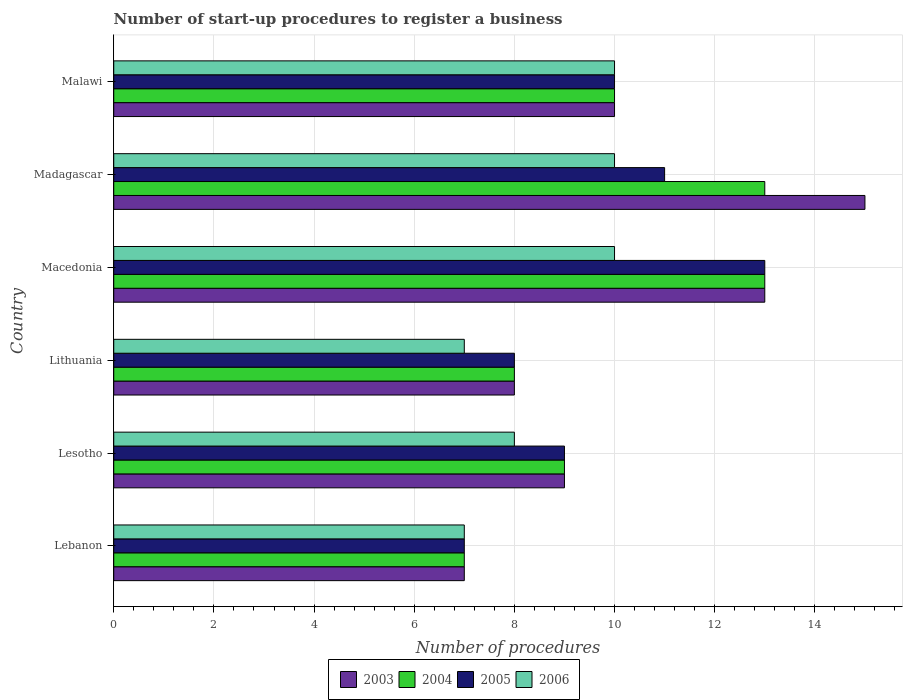How many different coloured bars are there?
Ensure brevity in your answer.  4. How many groups of bars are there?
Your answer should be compact. 6. Are the number of bars per tick equal to the number of legend labels?
Keep it short and to the point. Yes. Are the number of bars on each tick of the Y-axis equal?
Offer a very short reply. Yes. How many bars are there on the 4th tick from the top?
Offer a very short reply. 4. What is the label of the 6th group of bars from the top?
Provide a short and direct response. Lebanon. In which country was the number of procedures required to register a business in 2006 maximum?
Offer a terse response. Macedonia. In which country was the number of procedures required to register a business in 2005 minimum?
Make the answer very short. Lebanon. What is the total number of procedures required to register a business in 2003 in the graph?
Keep it short and to the point. 62. What is the difference between the number of procedures required to register a business in 2004 in Lesotho and that in Malawi?
Offer a terse response. -1. What is the average number of procedures required to register a business in 2004 per country?
Make the answer very short. 10. Is the number of procedures required to register a business in 2004 in Lithuania less than that in Macedonia?
Offer a very short reply. Yes. Is the difference between the number of procedures required to register a business in 2003 in Lesotho and Madagascar greater than the difference between the number of procedures required to register a business in 2005 in Lesotho and Madagascar?
Offer a very short reply. No. What is the difference between the highest and the lowest number of procedures required to register a business in 2004?
Provide a succinct answer. 6. Is the sum of the number of procedures required to register a business in 2006 in Macedonia and Malawi greater than the maximum number of procedures required to register a business in 2003 across all countries?
Keep it short and to the point. Yes. Is it the case that in every country, the sum of the number of procedures required to register a business in 2003 and number of procedures required to register a business in 2006 is greater than the number of procedures required to register a business in 2004?
Keep it short and to the point. Yes. How many bars are there?
Your answer should be compact. 24. What is the difference between two consecutive major ticks on the X-axis?
Provide a short and direct response. 2. Does the graph contain grids?
Offer a very short reply. Yes. What is the title of the graph?
Ensure brevity in your answer.  Number of start-up procedures to register a business. Does "1994" appear as one of the legend labels in the graph?
Give a very brief answer. No. What is the label or title of the X-axis?
Your response must be concise. Number of procedures. What is the label or title of the Y-axis?
Your answer should be very brief. Country. What is the Number of procedures of 2003 in Lebanon?
Offer a very short reply. 7. What is the Number of procedures of 2004 in Lebanon?
Your answer should be very brief. 7. What is the Number of procedures in 2005 in Lebanon?
Offer a terse response. 7. What is the Number of procedures of 2006 in Lebanon?
Give a very brief answer. 7. What is the Number of procedures in 2003 in Lesotho?
Your answer should be very brief. 9. What is the Number of procedures of 2004 in Lesotho?
Give a very brief answer. 9. What is the Number of procedures in 2006 in Lesotho?
Ensure brevity in your answer.  8. What is the Number of procedures of 2006 in Lithuania?
Your answer should be compact. 7. What is the Number of procedures in 2005 in Macedonia?
Your response must be concise. 13. What is the Number of procedures of 2004 in Madagascar?
Give a very brief answer. 13. What is the Number of procedures in 2006 in Madagascar?
Make the answer very short. 10. What is the Number of procedures in 2004 in Malawi?
Your answer should be very brief. 10. What is the Number of procedures of 2005 in Malawi?
Make the answer very short. 10. Across all countries, what is the maximum Number of procedures in 2003?
Provide a succinct answer. 15. Across all countries, what is the maximum Number of procedures in 2004?
Make the answer very short. 13. Across all countries, what is the maximum Number of procedures of 2006?
Keep it short and to the point. 10. Across all countries, what is the minimum Number of procedures of 2003?
Your answer should be very brief. 7. Across all countries, what is the minimum Number of procedures in 2004?
Offer a very short reply. 7. Across all countries, what is the minimum Number of procedures of 2005?
Offer a terse response. 7. Across all countries, what is the minimum Number of procedures in 2006?
Make the answer very short. 7. What is the total Number of procedures of 2003 in the graph?
Offer a very short reply. 62. What is the total Number of procedures of 2004 in the graph?
Your answer should be very brief. 60. What is the total Number of procedures in 2005 in the graph?
Offer a very short reply. 58. What is the difference between the Number of procedures in 2004 in Lebanon and that in Lesotho?
Provide a succinct answer. -2. What is the difference between the Number of procedures in 2006 in Lebanon and that in Lesotho?
Ensure brevity in your answer.  -1. What is the difference between the Number of procedures of 2004 in Lebanon and that in Lithuania?
Give a very brief answer. -1. What is the difference between the Number of procedures of 2005 in Lebanon and that in Lithuania?
Make the answer very short. -1. What is the difference between the Number of procedures of 2003 in Lebanon and that in Macedonia?
Offer a very short reply. -6. What is the difference between the Number of procedures of 2004 in Lebanon and that in Macedonia?
Offer a very short reply. -6. What is the difference between the Number of procedures of 2005 in Lebanon and that in Macedonia?
Give a very brief answer. -6. What is the difference between the Number of procedures of 2003 in Lebanon and that in Madagascar?
Ensure brevity in your answer.  -8. What is the difference between the Number of procedures of 2004 in Lebanon and that in Madagascar?
Offer a terse response. -6. What is the difference between the Number of procedures of 2005 in Lebanon and that in Madagascar?
Make the answer very short. -4. What is the difference between the Number of procedures of 2006 in Lebanon and that in Madagascar?
Ensure brevity in your answer.  -3. What is the difference between the Number of procedures of 2004 in Lebanon and that in Malawi?
Keep it short and to the point. -3. What is the difference between the Number of procedures in 2006 in Lebanon and that in Malawi?
Provide a short and direct response. -3. What is the difference between the Number of procedures of 2004 in Lesotho and that in Lithuania?
Provide a short and direct response. 1. What is the difference between the Number of procedures in 2006 in Lesotho and that in Lithuania?
Offer a very short reply. 1. What is the difference between the Number of procedures in 2003 in Lesotho and that in Macedonia?
Provide a succinct answer. -4. What is the difference between the Number of procedures of 2004 in Lesotho and that in Macedonia?
Give a very brief answer. -4. What is the difference between the Number of procedures of 2003 in Lesotho and that in Madagascar?
Your answer should be very brief. -6. What is the difference between the Number of procedures in 2005 in Lesotho and that in Madagascar?
Provide a succinct answer. -2. What is the difference between the Number of procedures of 2006 in Lesotho and that in Madagascar?
Offer a terse response. -2. What is the difference between the Number of procedures of 2003 in Lesotho and that in Malawi?
Make the answer very short. -1. What is the difference between the Number of procedures in 2004 in Lesotho and that in Malawi?
Provide a succinct answer. -1. What is the difference between the Number of procedures in 2005 in Lesotho and that in Malawi?
Make the answer very short. -1. What is the difference between the Number of procedures of 2006 in Lithuania and that in Macedonia?
Provide a short and direct response. -3. What is the difference between the Number of procedures in 2004 in Lithuania and that in Malawi?
Provide a short and direct response. -2. What is the difference between the Number of procedures in 2005 in Lithuania and that in Malawi?
Ensure brevity in your answer.  -2. What is the difference between the Number of procedures in 2003 in Macedonia and that in Madagascar?
Your answer should be very brief. -2. What is the difference between the Number of procedures in 2004 in Macedonia and that in Madagascar?
Give a very brief answer. 0. What is the difference between the Number of procedures in 2003 in Macedonia and that in Malawi?
Offer a very short reply. 3. What is the difference between the Number of procedures of 2005 in Macedonia and that in Malawi?
Offer a very short reply. 3. What is the difference between the Number of procedures of 2006 in Macedonia and that in Malawi?
Your answer should be very brief. 0. What is the difference between the Number of procedures of 2003 in Madagascar and that in Malawi?
Your response must be concise. 5. What is the difference between the Number of procedures of 2004 in Madagascar and that in Malawi?
Your response must be concise. 3. What is the difference between the Number of procedures in 2006 in Madagascar and that in Malawi?
Your response must be concise. 0. What is the difference between the Number of procedures in 2003 in Lebanon and the Number of procedures in 2005 in Lesotho?
Offer a very short reply. -2. What is the difference between the Number of procedures in 2004 in Lebanon and the Number of procedures in 2006 in Lesotho?
Ensure brevity in your answer.  -1. What is the difference between the Number of procedures of 2005 in Lebanon and the Number of procedures of 2006 in Lesotho?
Offer a very short reply. -1. What is the difference between the Number of procedures in 2003 in Lebanon and the Number of procedures in 2005 in Lithuania?
Offer a very short reply. -1. What is the difference between the Number of procedures of 2003 in Lebanon and the Number of procedures of 2006 in Lithuania?
Offer a terse response. 0. What is the difference between the Number of procedures of 2004 in Lebanon and the Number of procedures of 2006 in Lithuania?
Provide a succinct answer. 0. What is the difference between the Number of procedures of 2003 in Lebanon and the Number of procedures of 2004 in Macedonia?
Your response must be concise. -6. What is the difference between the Number of procedures in 2004 in Lebanon and the Number of procedures in 2006 in Macedonia?
Make the answer very short. -3. What is the difference between the Number of procedures in 2005 in Lebanon and the Number of procedures in 2006 in Macedonia?
Make the answer very short. -3. What is the difference between the Number of procedures of 2003 in Lebanon and the Number of procedures of 2005 in Madagascar?
Your response must be concise. -4. What is the difference between the Number of procedures of 2003 in Lebanon and the Number of procedures of 2006 in Madagascar?
Ensure brevity in your answer.  -3. What is the difference between the Number of procedures in 2004 in Lebanon and the Number of procedures in 2005 in Madagascar?
Provide a succinct answer. -4. What is the difference between the Number of procedures of 2005 in Lebanon and the Number of procedures of 2006 in Madagascar?
Keep it short and to the point. -3. What is the difference between the Number of procedures in 2004 in Lebanon and the Number of procedures in 2006 in Malawi?
Your answer should be compact. -3. What is the difference between the Number of procedures of 2003 in Lesotho and the Number of procedures of 2005 in Lithuania?
Provide a succinct answer. 1. What is the difference between the Number of procedures of 2003 in Lesotho and the Number of procedures of 2006 in Lithuania?
Ensure brevity in your answer.  2. What is the difference between the Number of procedures in 2004 in Lesotho and the Number of procedures in 2005 in Lithuania?
Provide a short and direct response. 1. What is the difference between the Number of procedures in 2004 in Lesotho and the Number of procedures in 2006 in Lithuania?
Your response must be concise. 2. What is the difference between the Number of procedures of 2005 in Lesotho and the Number of procedures of 2006 in Lithuania?
Provide a short and direct response. 2. What is the difference between the Number of procedures in 2003 in Lesotho and the Number of procedures in 2004 in Macedonia?
Provide a short and direct response. -4. What is the difference between the Number of procedures of 2003 in Lesotho and the Number of procedures of 2005 in Macedonia?
Offer a terse response. -4. What is the difference between the Number of procedures in 2004 in Lesotho and the Number of procedures in 2005 in Macedonia?
Keep it short and to the point. -4. What is the difference between the Number of procedures in 2004 in Lesotho and the Number of procedures in 2006 in Macedonia?
Provide a succinct answer. -1. What is the difference between the Number of procedures of 2003 in Lesotho and the Number of procedures of 2004 in Madagascar?
Make the answer very short. -4. What is the difference between the Number of procedures of 2003 in Lesotho and the Number of procedures of 2006 in Malawi?
Give a very brief answer. -1. What is the difference between the Number of procedures in 2003 in Lithuania and the Number of procedures in 2004 in Macedonia?
Make the answer very short. -5. What is the difference between the Number of procedures of 2003 in Lithuania and the Number of procedures of 2006 in Macedonia?
Give a very brief answer. -2. What is the difference between the Number of procedures of 2004 in Lithuania and the Number of procedures of 2005 in Macedonia?
Your response must be concise. -5. What is the difference between the Number of procedures in 2004 in Lithuania and the Number of procedures in 2006 in Macedonia?
Ensure brevity in your answer.  -2. What is the difference between the Number of procedures of 2005 in Lithuania and the Number of procedures of 2006 in Macedonia?
Make the answer very short. -2. What is the difference between the Number of procedures of 2003 in Lithuania and the Number of procedures of 2004 in Madagascar?
Your answer should be compact. -5. What is the difference between the Number of procedures in 2003 in Lithuania and the Number of procedures in 2005 in Madagascar?
Offer a very short reply. -3. What is the difference between the Number of procedures in 2004 in Lithuania and the Number of procedures in 2005 in Madagascar?
Give a very brief answer. -3. What is the difference between the Number of procedures in 2004 in Lithuania and the Number of procedures in 2006 in Madagascar?
Offer a terse response. -2. What is the difference between the Number of procedures of 2003 in Lithuania and the Number of procedures of 2004 in Malawi?
Your answer should be compact. -2. What is the difference between the Number of procedures in 2003 in Lithuania and the Number of procedures in 2005 in Malawi?
Keep it short and to the point. -2. What is the difference between the Number of procedures of 2005 in Lithuania and the Number of procedures of 2006 in Malawi?
Offer a terse response. -2. What is the difference between the Number of procedures of 2003 in Macedonia and the Number of procedures of 2004 in Madagascar?
Your response must be concise. 0. What is the difference between the Number of procedures of 2004 in Macedonia and the Number of procedures of 2005 in Madagascar?
Offer a terse response. 2. What is the difference between the Number of procedures of 2003 in Macedonia and the Number of procedures of 2006 in Malawi?
Offer a terse response. 3. What is the difference between the Number of procedures of 2004 in Macedonia and the Number of procedures of 2005 in Malawi?
Offer a very short reply. 3. What is the difference between the Number of procedures in 2004 in Macedonia and the Number of procedures in 2006 in Malawi?
Your answer should be very brief. 3. What is the difference between the Number of procedures of 2003 in Madagascar and the Number of procedures of 2006 in Malawi?
Give a very brief answer. 5. What is the average Number of procedures in 2003 per country?
Keep it short and to the point. 10.33. What is the average Number of procedures of 2004 per country?
Offer a terse response. 10. What is the average Number of procedures in 2005 per country?
Ensure brevity in your answer.  9.67. What is the average Number of procedures in 2006 per country?
Give a very brief answer. 8.67. What is the difference between the Number of procedures in 2003 and Number of procedures in 2004 in Lebanon?
Provide a succinct answer. 0. What is the difference between the Number of procedures in 2003 and Number of procedures in 2004 in Lesotho?
Keep it short and to the point. 0. What is the difference between the Number of procedures in 2003 and Number of procedures in 2006 in Lesotho?
Provide a short and direct response. 1. What is the difference between the Number of procedures of 2003 and Number of procedures of 2004 in Lithuania?
Ensure brevity in your answer.  0. What is the difference between the Number of procedures in 2004 and Number of procedures in 2005 in Lithuania?
Make the answer very short. 0. What is the difference between the Number of procedures in 2004 and Number of procedures in 2006 in Lithuania?
Your response must be concise. 1. What is the difference between the Number of procedures in 2005 and Number of procedures in 2006 in Lithuania?
Offer a terse response. 1. What is the difference between the Number of procedures of 2003 and Number of procedures of 2004 in Macedonia?
Give a very brief answer. 0. What is the difference between the Number of procedures of 2003 and Number of procedures of 2005 in Macedonia?
Your answer should be very brief. 0. What is the difference between the Number of procedures in 2003 and Number of procedures in 2006 in Macedonia?
Provide a short and direct response. 3. What is the difference between the Number of procedures of 2004 and Number of procedures of 2005 in Macedonia?
Make the answer very short. 0. What is the difference between the Number of procedures in 2005 and Number of procedures in 2006 in Macedonia?
Offer a very short reply. 3. What is the difference between the Number of procedures of 2004 and Number of procedures of 2006 in Madagascar?
Ensure brevity in your answer.  3. What is the difference between the Number of procedures in 2005 and Number of procedures in 2006 in Madagascar?
Your answer should be very brief. 1. What is the difference between the Number of procedures in 2003 and Number of procedures in 2005 in Malawi?
Ensure brevity in your answer.  0. What is the difference between the Number of procedures in 2005 and Number of procedures in 2006 in Malawi?
Give a very brief answer. 0. What is the ratio of the Number of procedures in 2006 in Lebanon to that in Lesotho?
Provide a succinct answer. 0.88. What is the ratio of the Number of procedures of 2003 in Lebanon to that in Macedonia?
Provide a succinct answer. 0.54. What is the ratio of the Number of procedures in 2004 in Lebanon to that in Macedonia?
Your response must be concise. 0.54. What is the ratio of the Number of procedures in 2005 in Lebanon to that in Macedonia?
Make the answer very short. 0.54. What is the ratio of the Number of procedures in 2006 in Lebanon to that in Macedonia?
Ensure brevity in your answer.  0.7. What is the ratio of the Number of procedures in 2003 in Lebanon to that in Madagascar?
Give a very brief answer. 0.47. What is the ratio of the Number of procedures in 2004 in Lebanon to that in Madagascar?
Ensure brevity in your answer.  0.54. What is the ratio of the Number of procedures in 2005 in Lebanon to that in Madagascar?
Offer a terse response. 0.64. What is the ratio of the Number of procedures of 2003 in Lebanon to that in Malawi?
Give a very brief answer. 0.7. What is the ratio of the Number of procedures of 2006 in Lebanon to that in Malawi?
Provide a succinct answer. 0.7. What is the ratio of the Number of procedures in 2004 in Lesotho to that in Lithuania?
Offer a terse response. 1.12. What is the ratio of the Number of procedures in 2006 in Lesotho to that in Lithuania?
Ensure brevity in your answer.  1.14. What is the ratio of the Number of procedures in 2003 in Lesotho to that in Macedonia?
Give a very brief answer. 0.69. What is the ratio of the Number of procedures of 2004 in Lesotho to that in Macedonia?
Make the answer very short. 0.69. What is the ratio of the Number of procedures in 2005 in Lesotho to that in Macedonia?
Your answer should be compact. 0.69. What is the ratio of the Number of procedures of 2006 in Lesotho to that in Macedonia?
Offer a very short reply. 0.8. What is the ratio of the Number of procedures of 2004 in Lesotho to that in Madagascar?
Offer a terse response. 0.69. What is the ratio of the Number of procedures of 2005 in Lesotho to that in Madagascar?
Keep it short and to the point. 0.82. What is the ratio of the Number of procedures in 2003 in Lesotho to that in Malawi?
Ensure brevity in your answer.  0.9. What is the ratio of the Number of procedures in 2006 in Lesotho to that in Malawi?
Your response must be concise. 0.8. What is the ratio of the Number of procedures of 2003 in Lithuania to that in Macedonia?
Offer a very short reply. 0.62. What is the ratio of the Number of procedures of 2004 in Lithuania to that in Macedonia?
Give a very brief answer. 0.62. What is the ratio of the Number of procedures of 2005 in Lithuania to that in Macedonia?
Provide a succinct answer. 0.62. What is the ratio of the Number of procedures of 2003 in Lithuania to that in Madagascar?
Offer a very short reply. 0.53. What is the ratio of the Number of procedures in 2004 in Lithuania to that in Madagascar?
Give a very brief answer. 0.62. What is the ratio of the Number of procedures of 2005 in Lithuania to that in Madagascar?
Your answer should be compact. 0.73. What is the ratio of the Number of procedures in 2003 in Lithuania to that in Malawi?
Offer a very short reply. 0.8. What is the ratio of the Number of procedures of 2004 in Lithuania to that in Malawi?
Offer a very short reply. 0.8. What is the ratio of the Number of procedures in 2003 in Macedonia to that in Madagascar?
Make the answer very short. 0.87. What is the ratio of the Number of procedures in 2004 in Macedonia to that in Madagascar?
Make the answer very short. 1. What is the ratio of the Number of procedures in 2005 in Macedonia to that in Madagascar?
Provide a short and direct response. 1.18. What is the ratio of the Number of procedures in 2006 in Macedonia to that in Madagascar?
Provide a succinct answer. 1. What is the ratio of the Number of procedures in 2006 in Macedonia to that in Malawi?
Offer a very short reply. 1. What is the ratio of the Number of procedures in 2004 in Madagascar to that in Malawi?
Keep it short and to the point. 1.3. What is the ratio of the Number of procedures of 2005 in Madagascar to that in Malawi?
Provide a short and direct response. 1.1. What is the ratio of the Number of procedures in 2006 in Madagascar to that in Malawi?
Ensure brevity in your answer.  1. What is the difference between the highest and the second highest Number of procedures in 2003?
Offer a terse response. 2. What is the difference between the highest and the second highest Number of procedures in 2006?
Your answer should be compact. 0. What is the difference between the highest and the lowest Number of procedures in 2005?
Offer a terse response. 6. What is the difference between the highest and the lowest Number of procedures of 2006?
Provide a short and direct response. 3. 